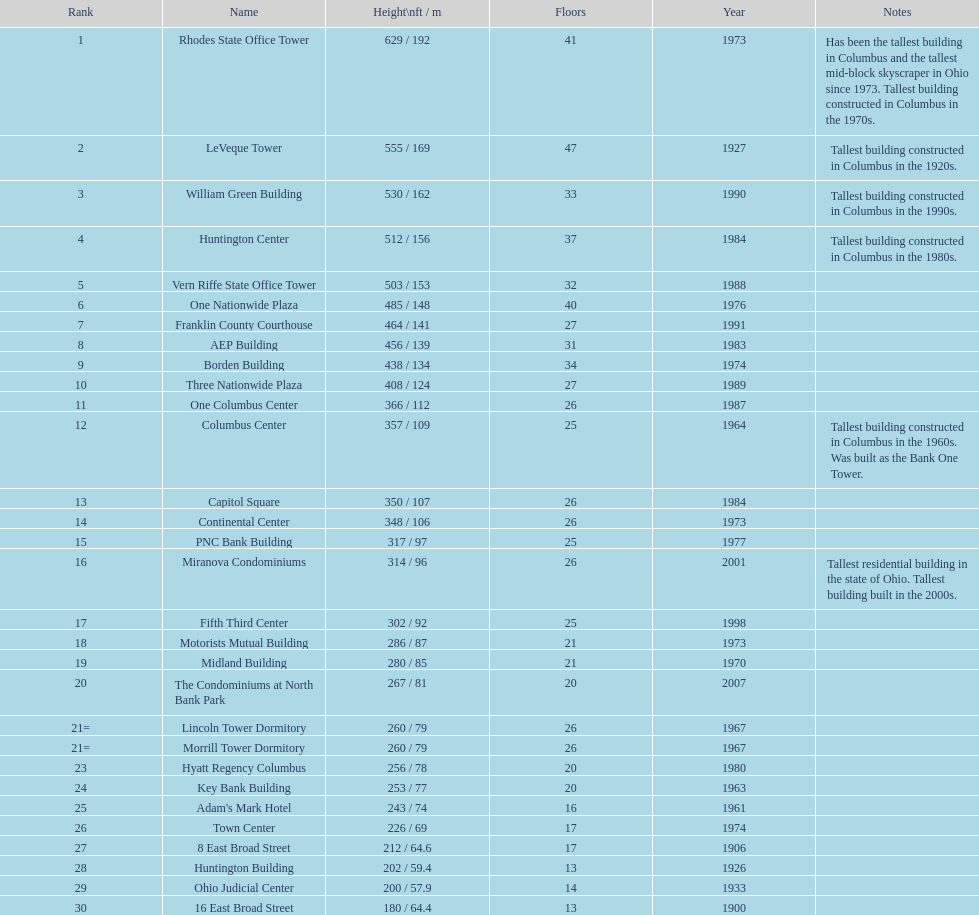What is the total number of floors in capitol square? 26. 